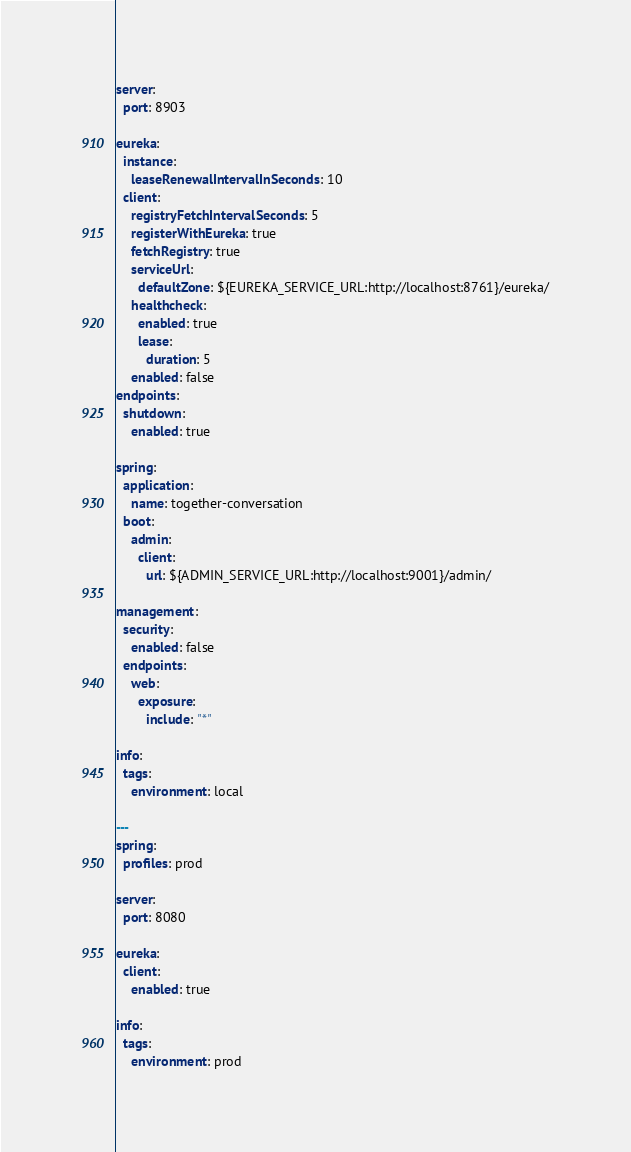<code> <loc_0><loc_0><loc_500><loc_500><_YAML_>server:
  port: 8903

eureka:
  instance:
    leaseRenewalIntervalInSeconds: 10
  client:
    registryFetchIntervalSeconds: 5
    registerWithEureka: true
    fetchRegistry: true
    serviceUrl:
      defaultZone: ${EUREKA_SERVICE_URL:http://localhost:8761}/eureka/
    healthcheck:
      enabled: true
      lease:
        duration: 5
    enabled: false
endpoints:
  shutdown:
    enabled: true

spring:
  application:
    name: together-conversation
  boot:
    admin:
      client:
        url: ${ADMIN_SERVICE_URL:http://localhost:9001}/admin/

management:
  security:
    enabled: false
  endpoints:
    web:
      exposure:
        include: "*"

info:
  tags:
    environment: local

---
spring:
  profiles: prod

server:
  port: 8080

eureka:
  client:
    enabled: true

info:
  tags:
    environment: prod
</code> 